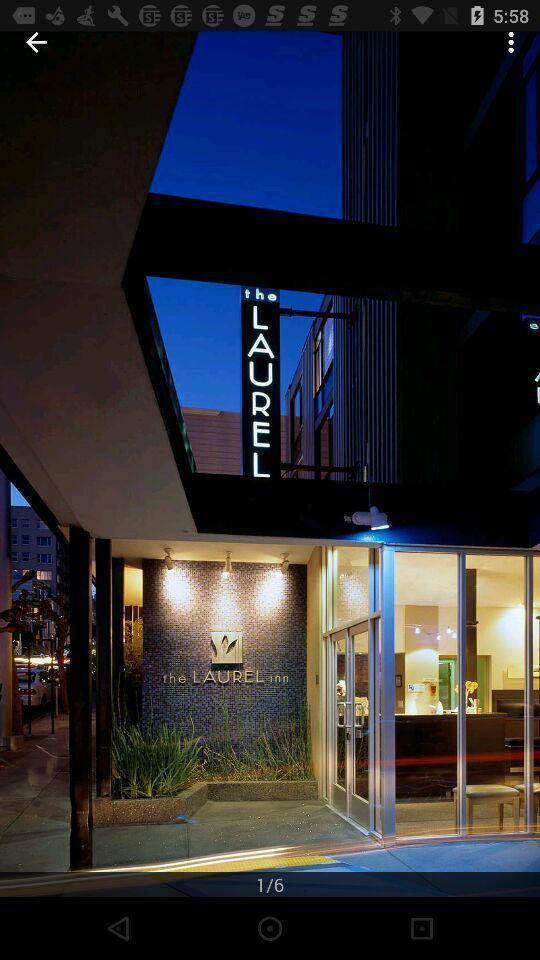Give me a narrative description of this picture. Page showing some images of a hotel. 